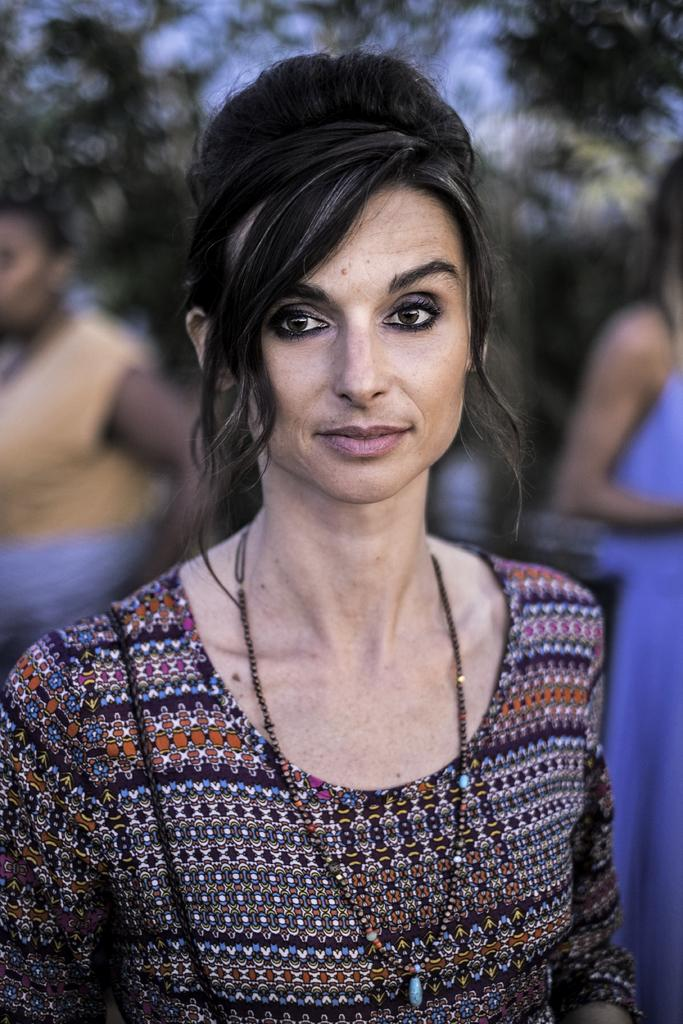What can be seen in the image? There are women standing in the image. What can be seen in the background of the image? There are trees visible in the background of the image. Can you describe the attire of one of the women? One of the women is wearing an ornament. Can you tell me how many light bulbs are hanging from the trees in the image? There are no light bulbs present in the image; it features women standing near trees. 